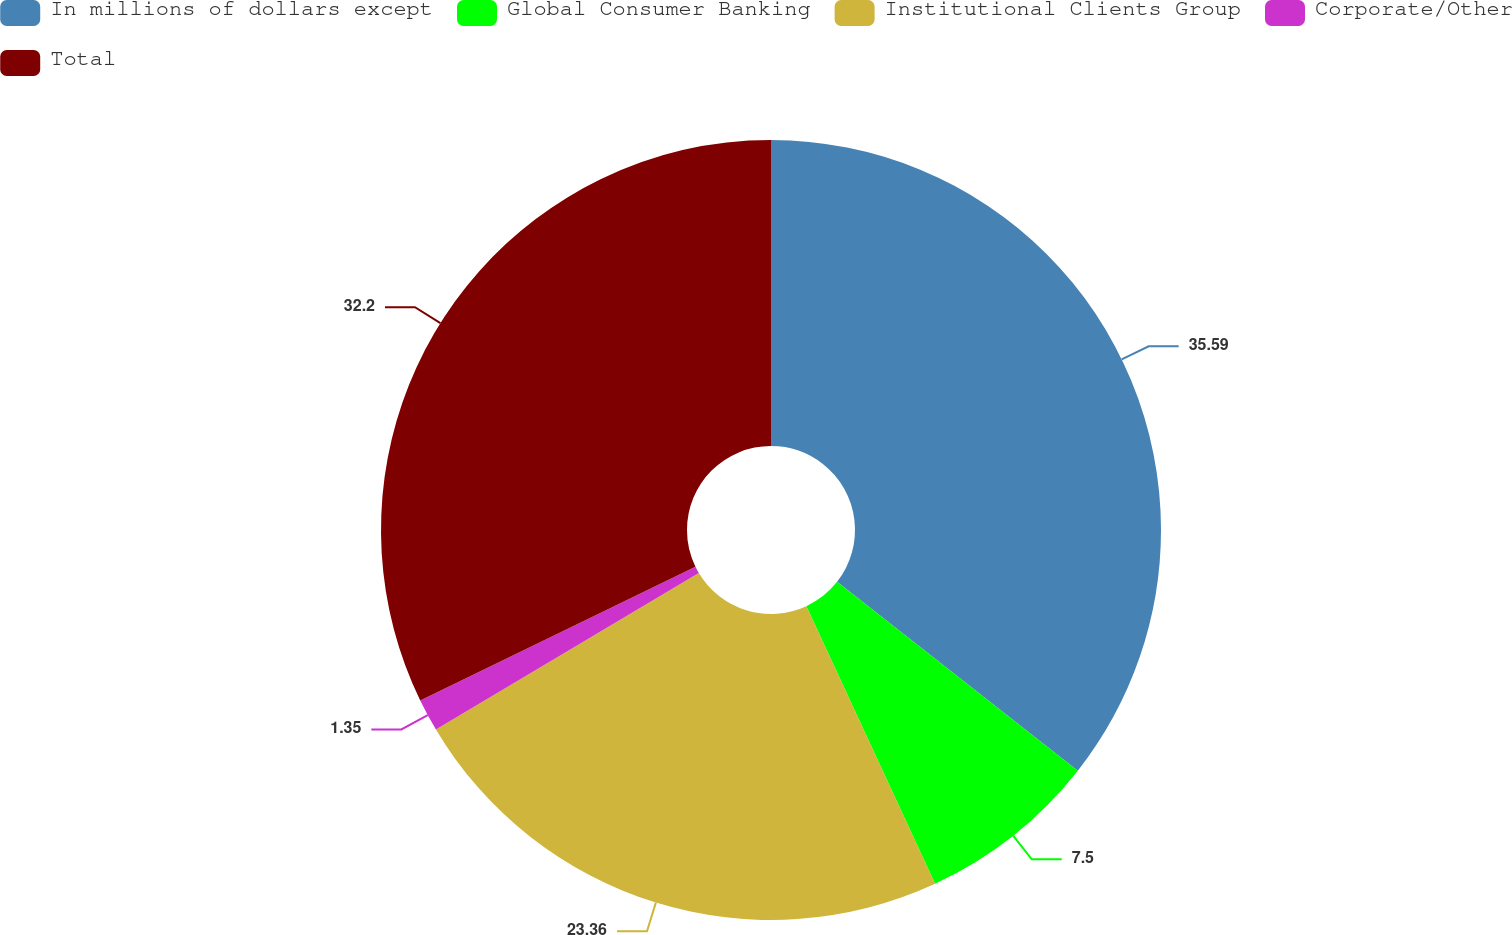Convert chart to OTSL. <chart><loc_0><loc_0><loc_500><loc_500><pie_chart><fcel>In millions of dollars except<fcel>Global Consumer Banking<fcel>Institutional Clients Group<fcel>Corporate/Other<fcel>Total<nl><fcel>35.59%<fcel>7.5%<fcel>23.36%<fcel>1.35%<fcel>32.2%<nl></chart> 